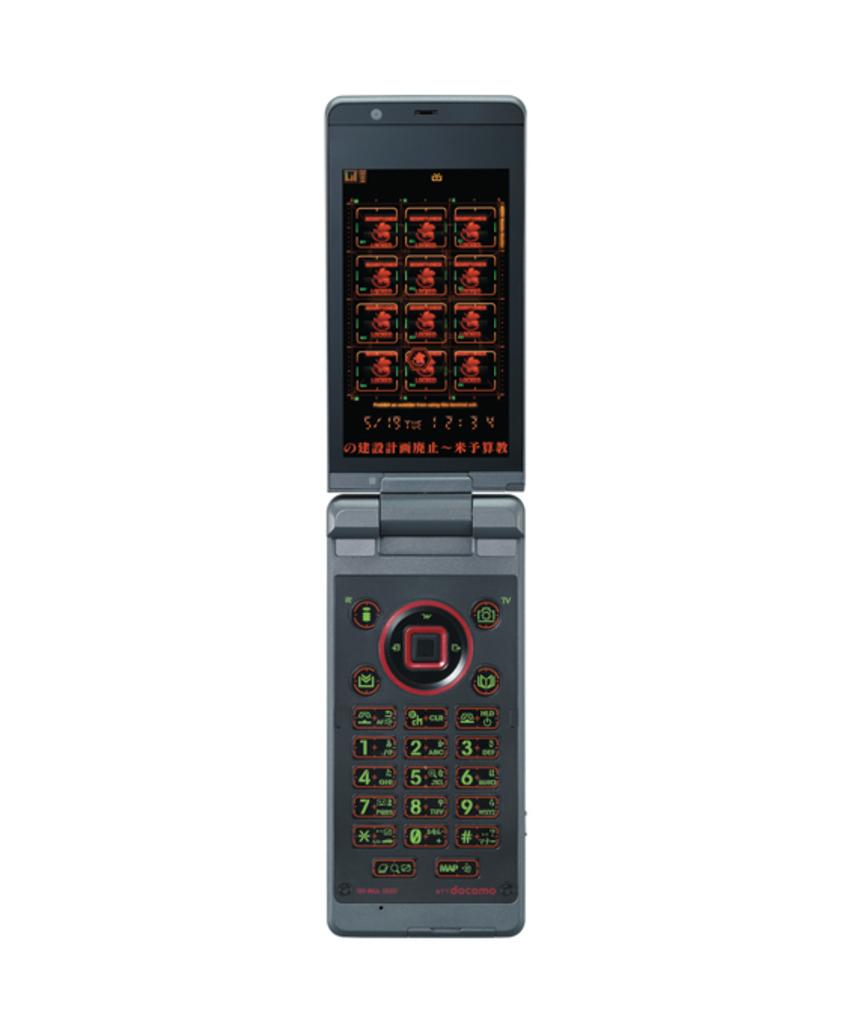What numbers are on this flip phone?
Offer a very short reply. 1234567890. Is the phone in english?
Ensure brevity in your answer.  No. 